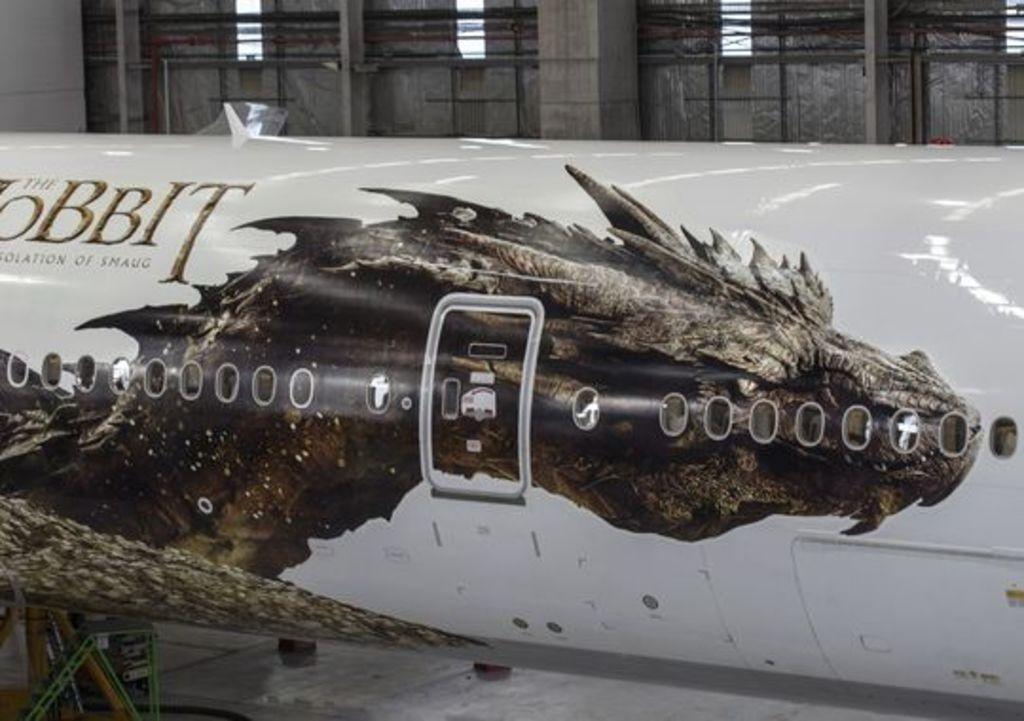Please provide a concise description of this image. In this picture we can see an airplane in the front, on the left side we can see some text, in the background there is a wall, we can see a door in the middle. 